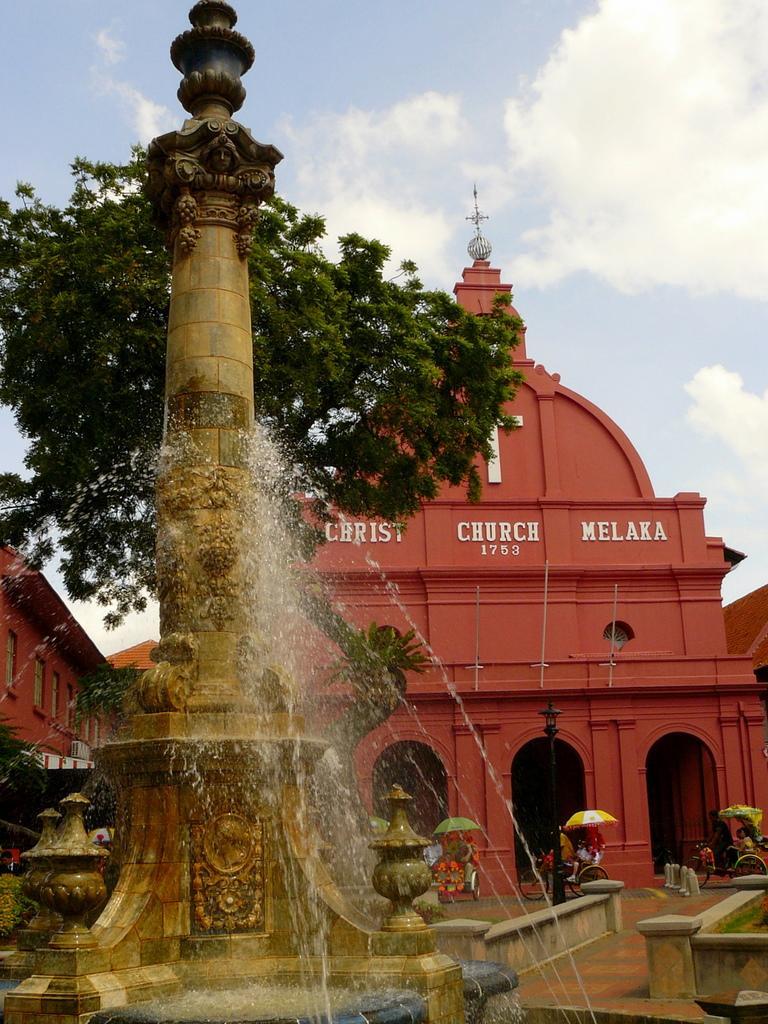How would you summarize this image in a sentence or two? In this image there is a fountain in the middle. In the background it looks like a church. In front of the church there are few people walking on the floor by holding the umbrellas. At the top there is the sky. Behind the fountain there is a tree. 